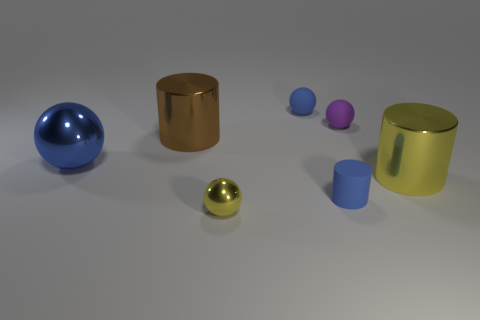Subtract 1 balls. How many balls are left? 3 Subtract all red spheres. Subtract all purple cylinders. How many spheres are left? 4 Add 2 small blue rubber spheres. How many objects exist? 9 Subtract all cylinders. How many objects are left? 4 Add 2 brown cylinders. How many brown cylinders are left? 3 Add 4 small yellow balls. How many small yellow balls exist? 5 Subtract 0 red blocks. How many objects are left? 7 Subtract all big yellow metallic objects. Subtract all small yellow metallic objects. How many objects are left? 5 